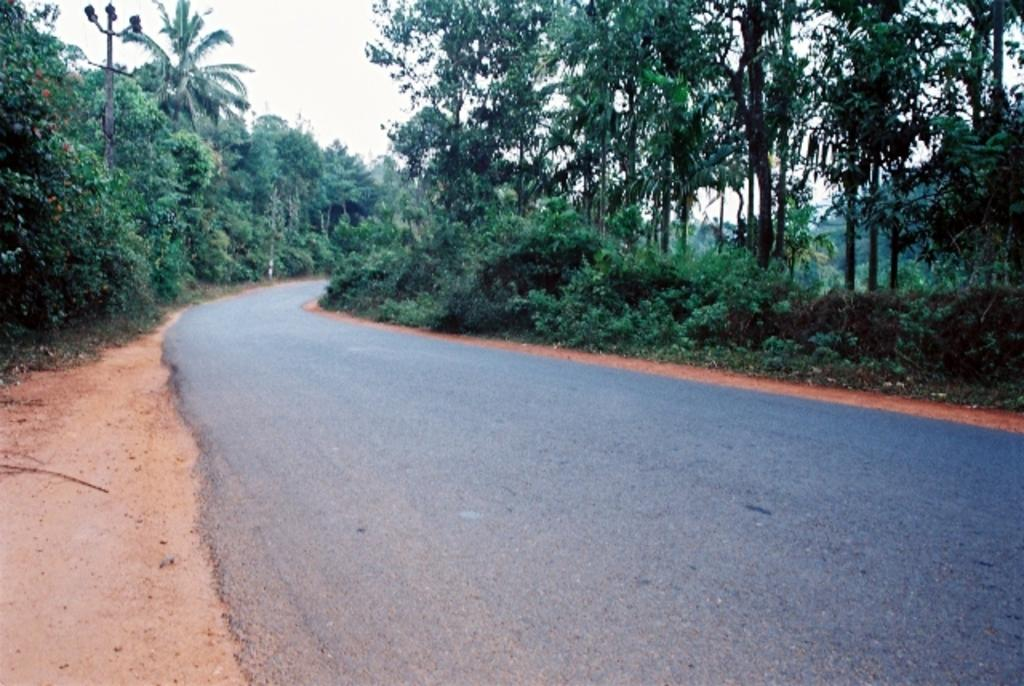What is located at the bottom of the image? There is a road at the bottom of the image. What can be seen in the background of the image? There are trees in the background of the image. What is visible at the top of the image? The sky is visible at the top of the image. How much salt is present on the road in the image? There is no salt present on the road in the image, as it is not mentioned in the provided facts. Who is the manager of the trees in the background of the image? There is no mention of a manager or any human involvement with the trees in the image, so this question cannot be answered definitively. 